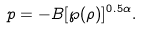<formula> <loc_0><loc_0><loc_500><loc_500>p = - B [ \wp ( \rho ) ] ^ { 0 . 5 \alpha } .</formula> 